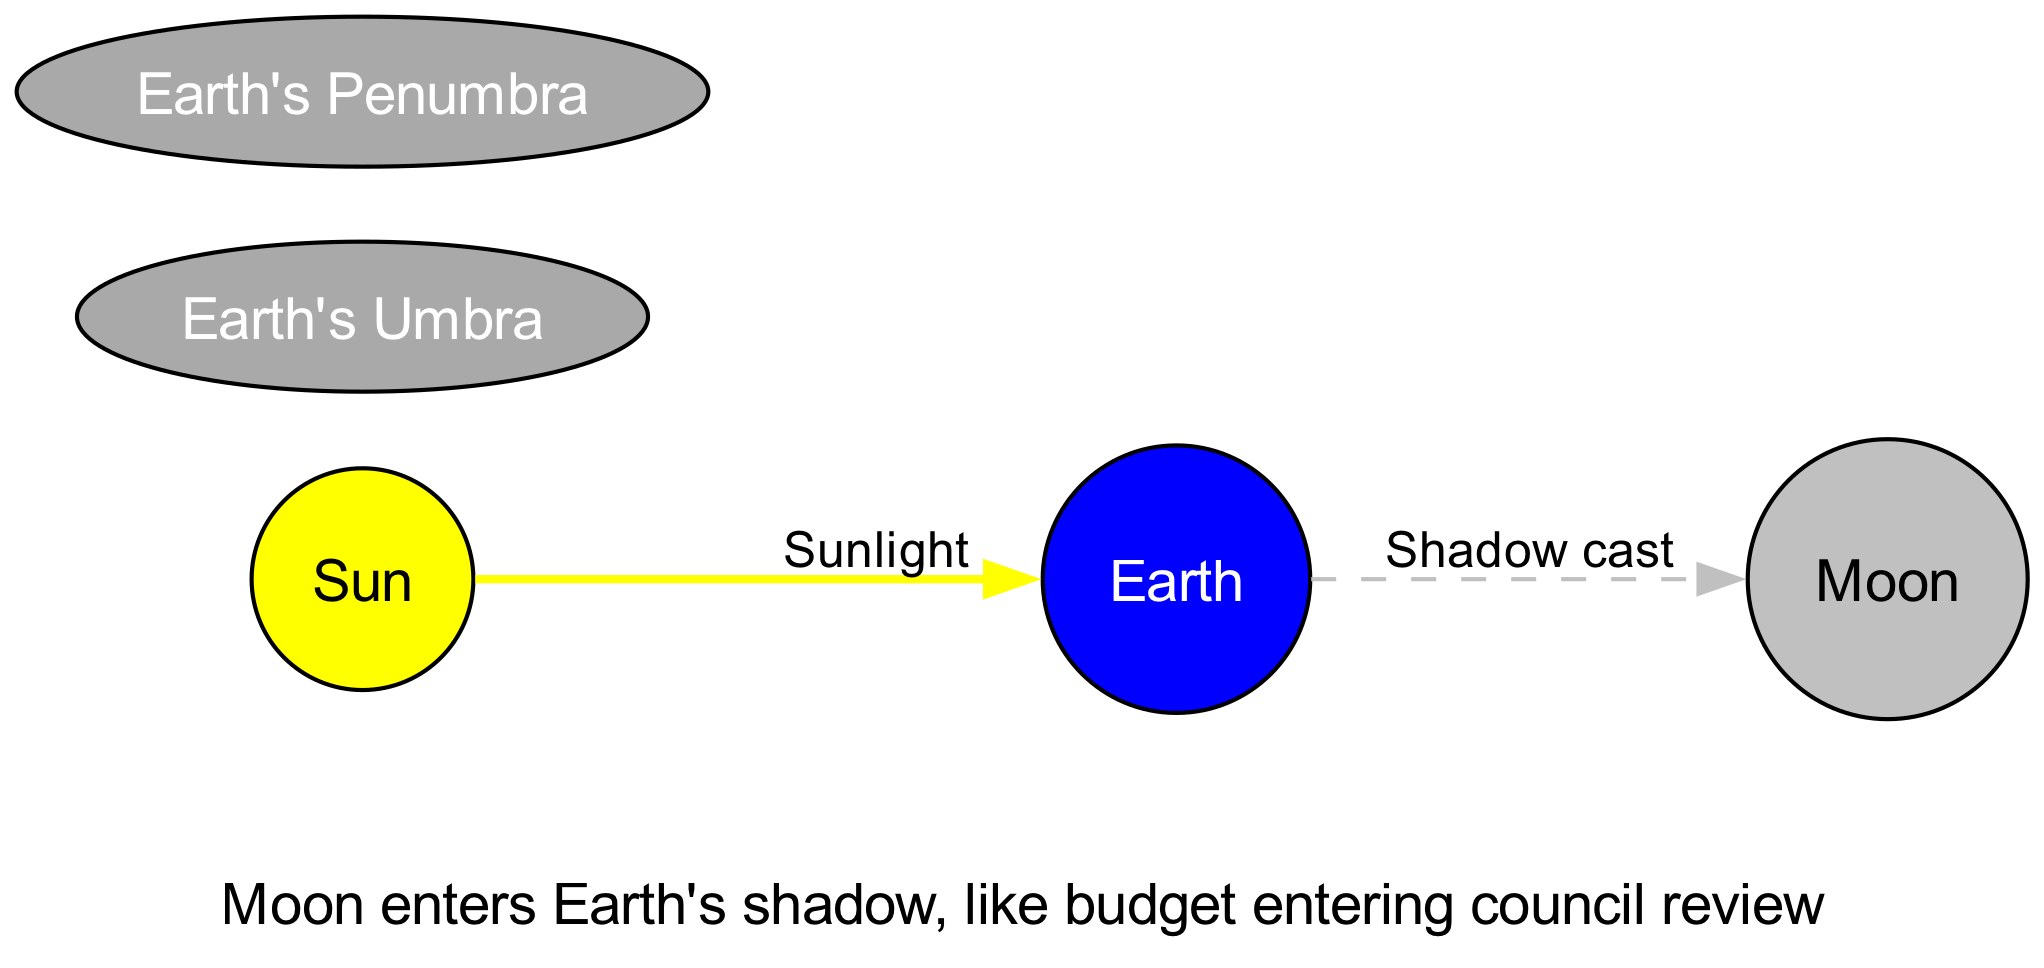What are the three celestial bodies illustrated in the diagram? The diagram shows the Sun, Earth, and Moon as the primary celestial bodies involved in the lunar eclipse. Each body is represented as a node, clearly labeled with text.
Answer: Sun, Earth, Moon What color represents the Earth in the diagram? The Earth node is filled with blue color, as indicated by its specified properties in the diagram's code.
Answer: Blue How many edges are present in the diagram? The diagram contains two edges, one representing sunlight from the Sun to the Earth and the other representing the shadow cast from the Earth to the Moon.
Answer: Two What does the Earth cast on the Moon during the lunar eclipse? The Earth casts a shadow on the Moon during the eclipse, as indicated by the labeled edge between the Earth and Moon in the diagram.
Answer: Shadow What type of shadow is mentioned in the diagram? The diagram identifies two types of shadows: umbra and penumbra, indicated by separate nodes for each type.
Answer: Umbra, Penumbra What alignment of celestial bodies is depicted in this diagram? The diagram illustrates the alignment of the Sun, Earth, and Moon, highlighting their positions in relation to one another during a lunar eclipse.
Answer: Sun, Earth, Moon In the diagram, what event is described as "Nature's celestial policy in action"? This phrase is the annotation at the top of the diagram, describing the overall phenomenon of the lunar eclipse occurring when the Moon enters the Earth's shadow.
Answer: Lunar Eclipse What does the annotation at the bottom compare the Moon entering Earth's shadow to? The bottom annotation compares the Moon entering the Earth's shadow to a budget entering council review, metaphorically linking the celestial event to a municipal process.
Answer: Budget entering council review What is the primary source of light for the Earth in the diagram? The main source of light is the Sun, as indicated by the labeled edge showing sunlight entering the Earth.
Answer: Sunlight 